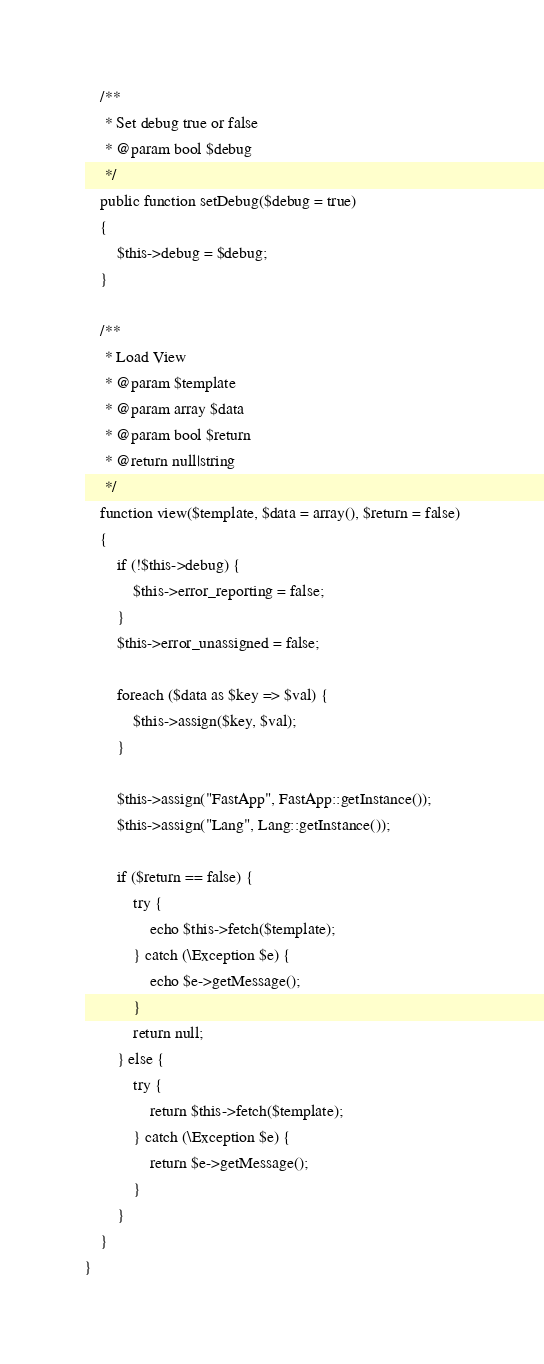<code> <loc_0><loc_0><loc_500><loc_500><_PHP_>
    /**
     * Set debug true or false
     * @param bool $debug
     */
    public function setDebug($debug = true)
    {
        $this->debug = $debug;
    }

    /**
     * Load View
     * @param $template
     * @param array $data
     * @param bool $return
     * @return null|string
     */
    function view($template, $data = array(), $return = false)
    {
        if (!$this->debug) {
            $this->error_reporting = false;
        }
        $this->error_unassigned = false;

        foreach ($data as $key => $val) {
            $this->assign($key, $val);
        }

        $this->assign("FastApp", FastApp::getInstance());
        $this->assign("Lang", Lang::getInstance());

        if ($return == false) {
            try {
                echo $this->fetch($template);
            } catch (\Exception $e) {
                echo $e->getMessage();
            }
            return null;
        } else {
            try {
                return $this->fetch($template);
            } catch (\Exception $e) {
                return $e->getMessage();
            }
        }
    }
}</code> 